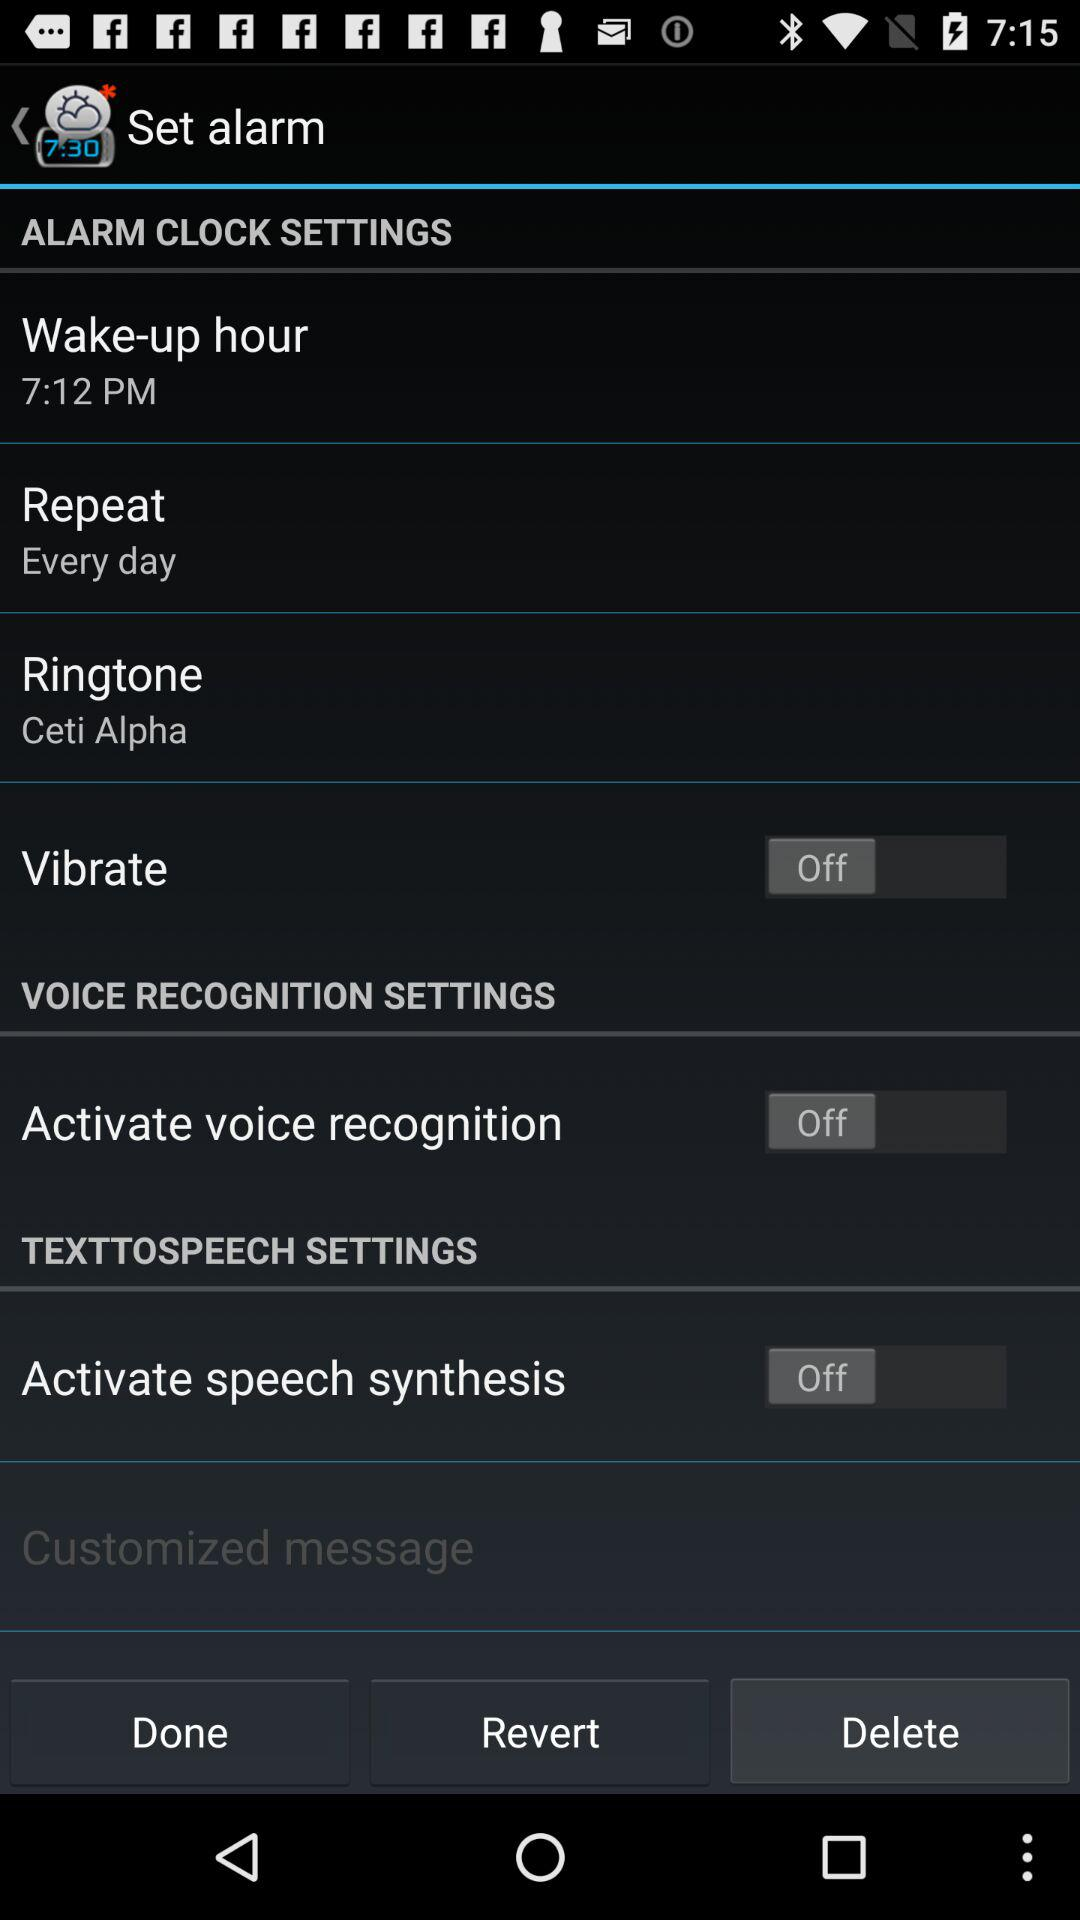Does the alarm repeat every day or just once? The alarm repeats every day. 